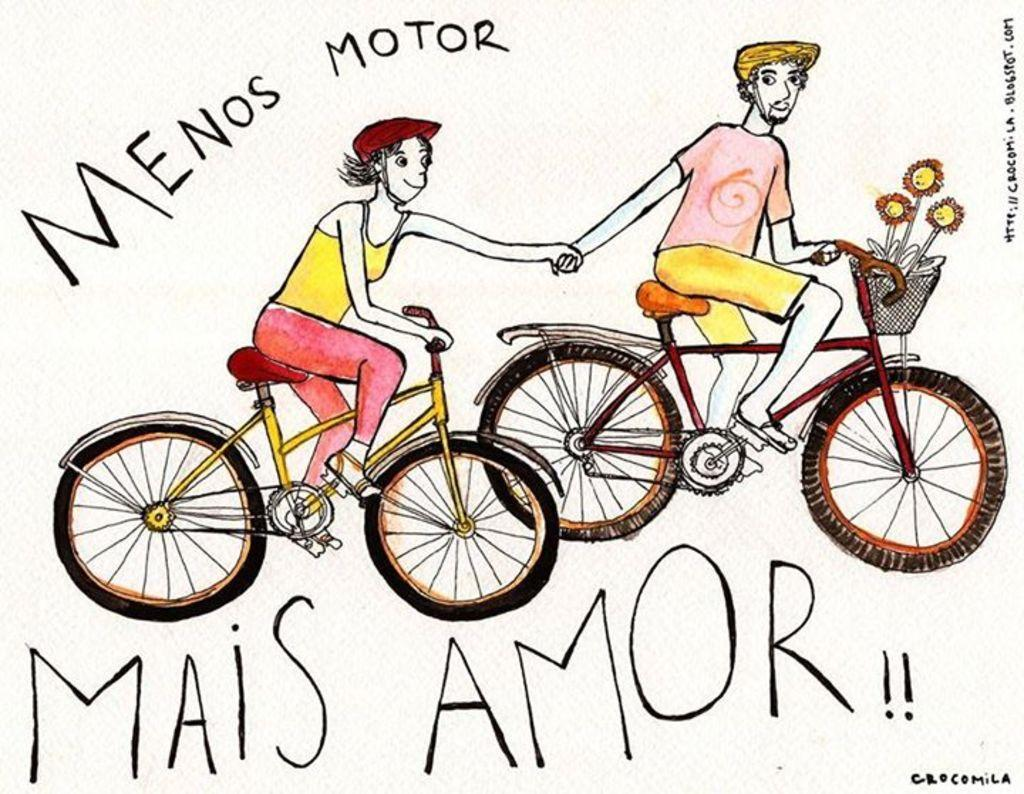What is the main subject of the drawing in the image? The main subject of the drawing in the image is two persons. What are the two persons doing in the drawing? The two persons are sitting on bicycles in the drawing. What other elements are present in the drawing? There are flowers depicted in the drawing. Is there any text within the drawing? Yes, there is text written in the image, specifically within the drawing. What type of noise can be heard coming from the circle in the image? There is no circle present in the image, and therefore no noise can be heard from it. 